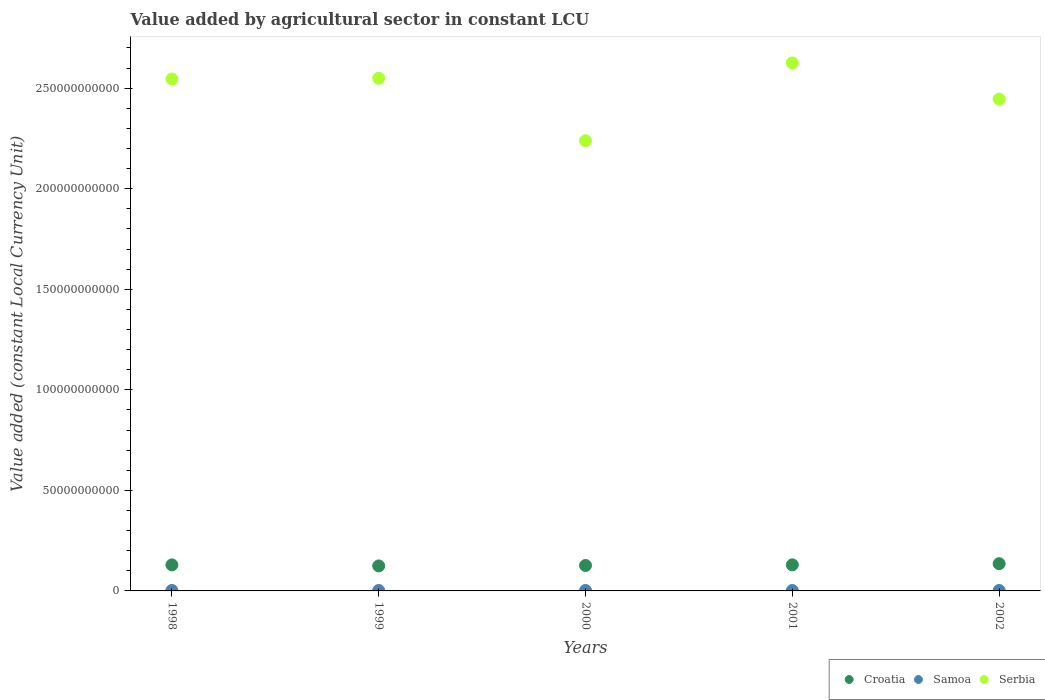Is the number of dotlines equal to the number of legend labels?
Offer a very short reply. Yes. What is the value added by agricultural sector in Serbia in 2001?
Your answer should be compact. 2.63e+11. Across all years, what is the maximum value added by agricultural sector in Croatia?
Provide a succinct answer. 1.35e+1. Across all years, what is the minimum value added by agricultural sector in Samoa?
Make the answer very short. 2.19e+08. In which year was the value added by agricultural sector in Croatia minimum?
Offer a very short reply. 1999. What is the total value added by agricultural sector in Croatia in the graph?
Offer a terse response. 6.46e+1. What is the difference between the value added by agricultural sector in Croatia in 2000 and that in 2001?
Your response must be concise. -3.09e+08. What is the difference between the value added by agricultural sector in Samoa in 1999 and the value added by agricultural sector in Serbia in 2000?
Provide a succinct answer. -2.24e+11. What is the average value added by agricultural sector in Samoa per year?
Offer a very short reply. 2.25e+08. In the year 1999, what is the difference between the value added by agricultural sector in Croatia and value added by agricultural sector in Samoa?
Offer a very short reply. 1.22e+1. What is the ratio of the value added by agricultural sector in Serbia in 1998 to that in 1999?
Keep it short and to the point. 1. What is the difference between the highest and the second highest value added by agricultural sector in Serbia?
Provide a succinct answer. 7.58e+09. What is the difference between the highest and the lowest value added by agricultural sector in Serbia?
Keep it short and to the point. 3.87e+1. In how many years, is the value added by agricultural sector in Samoa greater than the average value added by agricultural sector in Samoa taken over all years?
Provide a short and direct response. 3. Is the sum of the value added by agricultural sector in Croatia in 1998 and 1999 greater than the maximum value added by agricultural sector in Samoa across all years?
Your response must be concise. Yes. Is it the case that in every year, the sum of the value added by agricultural sector in Serbia and value added by agricultural sector in Croatia  is greater than the value added by agricultural sector in Samoa?
Provide a succinct answer. Yes. Is the value added by agricultural sector in Serbia strictly greater than the value added by agricultural sector in Croatia over the years?
Your answer should be very brief. Yes. Is the value added by agricultural sector in Serbia strictly less than the value added by agricultural sector in Samoa over the years?
Provide a short and direct response. No. How many dotlines are there?
Keep it short and to the point. 3. How many years are there in the graph?
Your answer should be very brief. 5. Does the graph contain any zero values?
Your response must be concise. No. Does the graph contain grids?
Ensure brevity in your answer.  No. Where does the legend appear in the graph?
Ensure brevity in your answer.  Bottom right. How many legend labels are there?
Make the answer very short. 3. How are the legend labels stacked?
Your answer should be very brief. Horizontal. What is the title of the graph?
Provide a succinct answer. Value added by agricultural sector in constant LCU. What is the label or title of the Y-axis?
Keep it short and to the point. Value added (constant Local Currency Unit). What is the Value added (constant Local Currency Unit) in Croatia in 1998?
Ensure brevity in your answer.  1.29e+1. What is the Value added (constant Local Currency Unit) of Samoa in 1998?
Provide a succinct answer. 2.33e+08. What is the Value added (constant Local Currency Unit) in Serbia in 1998?
Your response must be concise. 2.55e+11. What is the Value added (constant Local Currency Unit) in Croatia in 1999?
Give a very brief answer. 1.24e+1. What is the Value added (constant Local Currency Unit) of Samoa in 1999?
Keep it short and to the point. 2.26e+08. What is the Value added (constant Local Currency Unit) of Serbia in 1999?
Provide a succinct answer. 2.55e+11. What is the Value added (constant Local Currency Unit) in Croatia in 2000?
Your answer should be very brief. 1.27e+1. What is the Value added (constant Local Currency Unit) in Samoa in 2000?
Offer a very short reply. 2.26e+08. What is the Value added (constant Local Currency Unit) in Serbia in 2000?
Your answer should be very brief. 2.24e+11. What is the Value added (constant Local Currency Unit) in Croatia in 2001?
Your response must be concise. 1.30e+1. What is the Value added (constant Local Currency Unit) of Samoa in 2001?
Your answer should be very brief. 2.19e+08. What is the Value added (constant Local Currency Unit) in Serbia in 2001?
Give a very brief answer. 2.63e+11. What is the Value added (constant Local Currency Unit) of Croatia in 2002?
Make the answer very short. 1.35e+1. What is the Value added (constant Local Currency Unit) in Samoa in 2002?
Offer a terse response. 2.19e+08. What is the Value added (constant Local Currency Unit) of Serbia in 2002?
Ensure brevity in your answer.  2.45e+11. Across all years, what is the maximum Value added (constant Local Currency Unit) of Croatia?
Provide a succinct answer. 1.35e+1. Across all years, what is the maximum Value added (constant Local Currency Unit) in Samoa?
Ensure brevity in your answer.  2.33e+08. Across all years, what is the maximum Value added (constant Local Currency Unit) of Serbia?
Make the answer very short. 2.63e+11. Across all years, what is the minimum Value added (constant Local Currency Unit) in Croatia?
Your answer should be very brief. 1.24e+1. Across all years, what is the minimum Value added (constant Local Currency Unit) of Samoa?
Offer a very short reply. 2.19e+08. Across all years, what is the minimum Value added (constant Local Currency Unit) in Serbia?
Keep it short and to the point. 2.24e+11. What is the total Value added (constant Local Currency Unit) of Croatia in the graph?
Offer a terse response. 6.46e+1. What is the total Value added (constant Local Currency Unit) of Samoa in the graph?
Keep it short and to the point. 1.12e+09. What is the total Value added (constant Local Currency Unit) in Serbia in the graph?
Offer a terse response. 1.24e+12. What is the difference between the Value added (constant Local Currency Unit) of Croatia in 1998 and that in 1999?
Provide a succinct answer. 5.02e+08. What is the difference between the Value added (constant Local Currency Unit) of Samoa in 1998 and that in 1999?
Your response must be concise. 7.24e+06. What is the difference between the Value added (constant Local Currency Unit) of Serbia in 1998 and that in 1999?
Ensure brevity in your answer.  -3.89e+08. What is the difference between the Value added (constant Local Currency Unit) of Croatia in 1998 and that in 2000?
Ensure brevity in your answer.  2.76e+08. What is the difference between the Value added (constant Local Currency Unit) in Samoa in 1998 and that in 2000?
Offer a terse response. 7.12e+06. What is the difference between the Value added (constant Local Currency Unit) of Serbia in 1998 and that in 2000?
Offer a very short reply. 3.07e+1. What is the difference between the Value added (constant Local Currency Unit) in Croatia in 1998 and that in 2001?
Your answer should be compact. -3.24e+07. What is the difference between the Value added (constant Local Currency Unit) in Samoa in 1998 and that in 2001?
Your answer should be very brief. 1.42e+07. What is the difference between the Value added (constant Local Currency Unit) in Serbia in 1998 and that in 2001?
Ensure brevity in your answer.  -7.97e+09. What is the difference between the Value added (constant Local Currency Unit) of Croatia in 1998 and that in 2002?
Your response must be concise. -6.11e+08. What is the difference between the Value added (constant Local Currency Unit) in Samoa in 1998 and that in 2002?
Provide a short and direct response. 1.44e+07. What is the difference between the Value added (constant Local Currency Unit) in Serbia in 1998 and that in 2002?
Keep it short and to the point. 9.99e+09. What is the difference between the Value added (constant Local Currency Unit) in Croatia in 1999 and that in 2000?
Your response must be concise. -2.26e+08. What is the difference between the Value added (constant Local Currency Unit) in Samoa in 1999 and that in 2000?
Your answer should be compact. -1.27e+05. What is the difference between the Value added (constant Local Currency Unit) in Serbia in 1999 and that in 2000?
Your answer should be compact. 3.11e+1. What is the difference between the Value added (constant Local Currency Unit) in Croatia in 1999 and that in 2001?
Offer a terse response. -5.34e+08. What is the difference between the Value added (constant Local Currency Unit) of Samoa in 1999 and that in 2001?
Give a very brief answer. 6.94e+06. What is the difference between the Value added (constant Local Currency Unit) in Serbia in 1999 and that in 2001?
Offer a terse response. -7.58e+09. What is the difference between the Value added (constant Local Currency Unit) of Croatia in 1999 and that in 2002?
Offer a very short reply. -1.11e+09. What is the difference between the Value added (constant Local Currency Unit) in Samoa in 1999 and that in 2002?
Provide a succinct answer. 7.17e+06. What is the difference between the Value added (constant Local Currency Unit) of Serbia in 1999 and that in 2002?
Make the answer very short. 1.04e+1. What is the difference between the Value added (constant Local Currency Unit) in Croatia in 2000 and that in 2001?
Provide a succinct answer. -3.09e+08. What is the difference between the Value added (constant Local Currency Unit) of Samoa in 2000 and that in 2001?
Offer a terse response. 7.07e+06. What is the difference between the Value added (constant Local Currency Unit) in Serbia in 2000 and that in 2001?
Your answer should be compact. -3.87e+1. What is the difference between the Value added (constant Local Currency Unit) in Croatia in 2000 and that in 2002?
Your response must be concise. -8.87e+08. What is the difference between the Value added (constant Local Currency Unit) of Samoa in 2000 and that in 2002?
Your answer should be very brief. 7.30e+06. What is the difference between the Value added (constant Local Currency Unit) in Serbia in 2000 and that in 2002?
Give a very brief answer. -2.07e+1. What is the difference between the Value added (constant Local Currency Unit) of Croatia in 2001 and that in 2002?
Give a very brief answer. -5.79e+08. What is the difference between the Value added (constant Local Currency Unit) of Samoa in 2001 and that in 2002?
Provide a short and direct response. 2.29e+05. What is the difference between the Value added (constant Local Currency Unit) in Serbia in 2001 and that in 2002?
Give a very brief answer. 1.80e+1. What is the difference between the Value added (constant Local Currency Unit) in Croatia in 1998 and the Value added (constant Local Currency Unit) in Samoa in 1999?
Offer a very short reply. 1.27e+1. What is the difference between the Value added (constant Local Currency Unit) of Croatia in 1998 and the Value added (constant Local Currency Unit) of Serbia in 1999?
Make the answer very short. -2.42e+11. What is the difference between the Value added (constant Local Currency Unit) of Samoa in 1998 and the Value added (constant Local Currency Unit) of Serbia in 1999?
Keep it short and to the point. -2.55e+11. What is the difference between the Value added (constant Local Currency Unit) of Croatia in 1998 and the Value added (constant Local Currency Unit) of Samoa in 2000?
Offer a very short reply. 1.27e+1. What is the difference between the Value added (constant Local Currency Unit) of Croatia in 1998 and the Value added (constant Local Currency Unit) of Serbia in 2000?
Give a very brief answer. -2.11e+11. What is the difference between the Value added (constant Local Currency Unit) in Samoa in 1998 and the Value added (constant Local Currency Unit) in Serbia in 2000?
Provide a short and direct response. -2.24e+11. What is the difference between the Value added (constant Local Currency Unit) of Croatia in 1998 and the Value added (constant Local Currency Unit) of Samoa in 2001?
Your answer should be compact. 1.27e+1. What is the difference between the Value added (constant Local Currency Unit) in Croatia in 1998 and the Value added (constant Local Currency Unit) in Serbia in 2001?
Ensure brevity in your answer.  -2.50e+11. What is the difference between the Value added (constant Local Currency Unit) in Samoa in 1998 and the Value added (constant Local Currency Unit) in Serbia in 2001?
Your answer should be compact. -2.62e+11. What is the difference between the Value added (constant Local Currency Unit) of Croatia in 1998 and the Value added (constant Local Currency Unit) of Samoa in 2002?
Offer a very short reply. 1.27e+1. What is the difference between the Value added (constant Local Currency Unit) of Croatia in 1998 and the Value added (constant Local Currency Unit) of Serbia in 2002?
Your response must be concise. -2.32e+11. What is the difference between the Value added (constant Local Currency Unit) of Samoa in 1998 and the Value added (constant Local Currency Unit) of Serbia in 2002?
Provide a short and direct response. -2.44e+11. What is the difference between the Value added (constant Local Currency Unit) of Croatia in 1999 and the Value added (constant Local Currency Unit) of Samoa in 2000?
Your response must be concise. 1.22e+1. What is the difference between the Value added (constant Local Currency Unit) of Croatia in 1999 and the Value added (constant Local Currency Unit) of Serbia in 2000?
Your answer should be very brief. -2.11e+11. What is the difference between the Value added (constant Local Currency Unit) of Samoa in 1999 and the Value added (constant Local Currency Unit) of Serbia in 2000?
Provide a succinct answer. -2.24e+11. What is the difference between the Value added (constant Local Currency Unit) in Croatia in 1999 and the Value added (constant Local Currency Unit) in Samoa in 2001?
Provide a succinct answer. 1.22e+1. What is the difference between the Value added (constant Local Currency Unit) in Croatia in 1999 and the Value added (constant Local Currency Unit) in Serbia in 2001?
Provide a short and direct response. -2.50e+11. What is the difference between the Value added (constant Local Currency Unit) of Samoa in 1999 and the Value added (constant Local Currency Unit) of Serbia in 2001?
Offer a very short reply. -2.62e+11. What is the difference between the Value added (constant Local Currency Unit) in Croatia in 1999 and the Value added (constant Local Currency Unit) in Samoa in 2002?
Keep it short and to the point. 1.22e+1. What is the difference between the Value added (constant Local Currency Unit) of Croatia in 1999 and the Value added (constant Local Currency Unit) of Serbia in 2002?
Keep it short and to the point. -2.32e+11. What is the difference between the Value added (constant Local Currency Unit) in Samoa in 1999 and the Value added (constant Local Currency Unit) in Serbia in 2002?
Offer a very short reply. -2.44e+11. What is the difference between the Value added (constant Local Currency Unit) in Croatia in 2000 and the Value added (constant Local Currency Unit) in Samoa in 2001?
Offer a terse response. 1.24e+1. What is the difference between the Value added (constant Local Currency Unit) of Croatia in 2000 and the Value added (constant Local Currency Unit) of Serbia in 2001?
Make the answer very short. -2.50e+11. What is the difference between the Value added (constant Local Currency Unit) of Samoa in 2000 and the Value added (constant Local Currency Unit) of Serbia in 2001?
Ensure brevity in your answer.  -2.62e+11. What is the difference between the Value added (constant Local Currency Unit) of Croatia in 2000 and the Value added (constant Local Currency Unit) of Samoa in 2002?
Keep it short and to the point. 1.24e+1. What is the difference between the Value added (constant Local Currency Unit) of Croatia in 2000 and the Value added (constant Local Currency Unit) of Serbia in 2002?
Ensure brevity in your answer.  -2.32e+11. What is the difference between the Value added (constant Local Currency Unit) of Samoa in 2000 and the Value added (constant Local Currency Unit) of Serbia in 2002?
Give a very brief answer. -2.44e+11. What is the difference between the Value added (constant Local Currency Unit) in Croatia in 2001 and the Value added (constant Local Currency Unit) in Samoa in 2002?
Offer a very short reply. 1.28e+1. What is the difference between the Value added (constant Local Currency Unit) of Croatia in 2001 and the Value added (constant Local Currency Unit) of Serbia in 2002?
Provide a succinct answer. -2.32e+11. What is the difference between the Value added (constant Local Currency Unit) of Samoa in 2001 and the Value added (constant Local Currency Unit) of Serbia in 2002?
Provide a succinct answer. -2.44e+11. What is the average Value added (constant Local Currency Unit) in Croatia per year?
Give a very brief answer. 1.29e+1. What is the average Value added (constant Local Currency Unit) of Samoa per year?
Ensure brevity in your answer.  2.25e+08. What is the average Value added (constant Local Currency Unit) in Serbia per year?
Ensure brevity in your answer.  2.48e+11. In the year 1998, what is the difference between the Value added (constant Local Currency Unit) of Croatia and Value added (constant Local Currency Unit) of Samoa?
Give a very brief answer. 1.27e+1. In the year 1998, what is the difference between the Value added (constant Local Currency Unit) of Croatia and Value added (constant Local Currency Unit) of Serbia?
Offer a very short reply. -2.42e+11. In the year 1998, what is the difference between the Value added (constant Local Currency Unit) in Samoa and Value added (constant Local Currency Unit) in Serbia?
Your answer should be compact. -2.54e+11. In the year 1999, what is the difference between the Value added (constant Local Currency Unit) of Croatia and Value added (constant Local Currency Unit) of Samoa?
Ensure brevity in your answer.  1.22e+1. In the year 1999, what is the difference between the Value added (constant Local Currency Unit) of Croatia and Value added (constant Local Currency Unit) of Serbia?
Provide a short and direct response. -2.43e+11. In the year 1999, what is the difference between the Value added (constant Local Currency Unit) of Samoa and Value added (constant Local Currency Unit) of Serbia?
Your response must be concise. -2.55e+11. In the year 2000, what is the difference between the Value added (constant Local Currency Unit) in Croatia and Value added (constant Local Currency Unit) in Samoa?
Ensure brevity in your answer.  1.24e+1. In the year 2000, what is the difference between the Value added (constant Local Currency Unit) in Croatia and Value added (constant Local Currency Unit) in Serbia?
Provide a short and direct response. -2.11e+11. In the year 2000, what is the difference between the Value added (constant Local Currency Unit) of Samoa and Value added (constant Local Currency Unit) of Serbia?
Your answer should be very brief. -2.24e+11. In the year 2001, what is the difference between the Value added (constant Local Currency Unit) of Croatia and Value added (constant Local Currency Unit) of Samoa?
Ensure brevity in your answer.  1.28e+1. In the year 2001, what is the difference between the Value added (constant Local Currency Unit) in Croatia and Value added (constant Local Currency Unit) in Serbia?
Your response must be concise. -2.50e+11. In the year 2001, what is the difference between the Value added (constant Local Currency Unit) of Samoa and Value added (constant Local Currency Unit) of Serbia?
Make the answer very short. -2.62e+11. In the year 2002, what is the difference between the Value added (constant Local Currency Unit) of Croatia and Value added (constant Local Currency Unit) of Samoa?
Provide a succinct answer. 1.33e+1. In the year 2002, what is the difference between the Value added (constant Local Currency Unit) in Croatia and Value added (constant Local Currency Unit) in Serbia?
Offer a terse response. -2.31e+11. In the year 2002, what is the difference between the Value added (constant Local Currency Unit) of Samoa and Value added (constant Local Currency Unit) of Serbia?
Offer a terse response. -2.44e+11. What is the ratio of the Value added (constant Local Currency Unit) in Croatia in 1998 to that in 1999?
Offer a very short reply. 1.04. What is the ratio of the Value added (constant Local Currency Unit) in Samoa in 1998 to that in 1999?
Provide a succinct answer. 1.03. What is the ratio of the Value added (constant Local Currency Unit) in Serbia in 1998 to that in 1999?
Your answer should be compact. 1. What is the ratio of the Value added (constant Local Currency Unit) of Croatia in 1998 to that in 2000?
Offer a terse response. 1.02. What is the ratio of the Value added (constant Local Currency Unit) of Samoa in 1998 to that in 2000?
Ensure brevity in your answer.  1.03. What is the ratio of the Value added (constant Local Currency Unit) in Serbia in 1998 to that in 2000?
Give a very brief answer. 1.14. What is the ratio of the Value added (constant Local Currency Unit) in Croatia in 1998 to that in 2001?
Give a very brief answer. 1. What is the ratio of the Value added (constant Local Currency Unit) of Samoa in 1998 to that in 2001?
Your answer should be very brief. 1.06. What is the ratio of the Value added (constant Local Currency Unit) of Serbia in 1998 to that in 2001?
Give a very brief answer. 0.97. What is the ratio of the Value added (constant Local Currency Unit) of Croatia in 1998 to that in 2002?
Provide a succinct answer. 0.95. What is the ratio of the Value added (constant Local Currency Unit) of Samoa in 1998 to that in 2002?
Give a very brief answer. 1.07. What is the ratio of the Value added (constant Local Currency Unit) of Serbia in 1998 to that in 2002?
Your response must be concise. 1.04. What is the ratio of the Value added (constant Local Currency Unit) in Croatia in 1999 to that in 2000?
Make the answer very short. 0.98. What is the ratio of the Value added (constant Local Currency Unit) of Samoa in 1999 to that in 2000?
Make the answer very short. 1. What is the ratio of the Value added (constant Local Currency Unit) of Serbia in 1999 to that in 2000?
Offer a very short reply. 1.14. What is the ratio of the Value added (constant Local Currency Unit) in Croatia in 1999 to that in 2001?
Ensure brevity in your answer.  0.96. What is the ratio of the Value added (constant Local Currency Unit) of Samoa in 1999 to that in 2001?
Give a very brief answer. 1.03. What is the ratio of the Value added (constant Local Currency Unit) in Serbia in 1999 to that in 2001?
Keep it short and to the point. 0.97. What is the ratio of the Value added (constant Local Currency Unit) in Croatia in 1999 to that in 2002?
Your response must be concise. 0.92. What is the ratio of the Value added (constant Local Currency Unit) of Samoa in 1999 to that in 2002?
Offer a very short reply. 1.03. What is the ratio of the Value added (constant Local Currency Unit) of Serbia in 1999 to that in 2002?
Provide a short and direct response. 1.04. What is the ratio of the Value added (constant Local Currency Unit) of Croatia in 2000 to that in 2001?
Your response must be concise. 0.98. What is the ratio of the Value added (constant Local Currency Unit) in Samoa in 2000 to that in 2001?
Keep it short and to the point. 1.03. What is the ratio of the Value added (constant Local Currency Unit) in Serbia in 2000 to that in 2001?
Offer a terse response. 0.85. What is the ratio of the Value added (constant Local Currency Unit) in Croatia in 2000 to that in 2002?
Keep it short and to the point. 0.93. What is the ratio of the Value added (constant Local Currency Unit) of Samoa in 2000 to that in 2002?
Offer a terse response. 1.03. What is the ratio of the Value added (constant Local Currency Unit) of Serbia in 2000 to that in 2002?
Ensure brevity in your answer.  0.92. What is the ratio of the Value added (constant Local Currency Unit) of Croatia in 2001 to that in 2002?
Provide a succinct answer. 0.96. What is the ratio of the Value added (constant Local Currency Unit) in Samoa in 2001 to that in 2002?
Your answer should be very brief. 1. What is the ratio of the Value added (constant Local Currency Unit) in Serbia in 2001 to that in 2002?
Keep it short and to the point. 1.07. What is the difference between the highest and the second highest Value added (constant Local Currency Unit) in Croatia?
Ensure brevity in your answer.  5.79e+08. What is the difference between the highest and the second highest Value added (constant Local Currency Unit) of Samoa?
Provide a succinct answer. 7.12e+06. What is the difference between the highest and the second highest Value added (constant Local Currency Unit) in Serbia?
Offer a very short reply. 7.58e+09. What is the difference between the highest and the lowest Value added (constant Local Currency Unit) in Croatia?
Provide a short and direct response. 1.11e+09. What is the difference between the highest and the lowest Value added (constant Local Currency Unit) of Samoa?
Your response must be concise. 1.44e+07. What is the difference between the highest and the lowest Value added (constant Local Currency Unit) in Serbia?
Your response must be concise. 3.87e+1. 